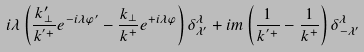<formula> <loc_0><loc_0><loc_500><loc_500>i \lambda \left ( \frac { k _ { \perp } ^ { \prime } } { k ^ { ^ { \prime } + } } e ^ { - i \lambda \varphi ^ { \prime } } - \frac { k _ { \perp } } { k ^ { + } } e ^ { + i \lambda \varphi } \right ) \delta _ { \lambda ^ { \prime } } ^ { \lambda } + i m \left ( \frac { 1 } { k ^ { ^ { \prime } + } } - \frac { 1 } { k ^ { + } } \right ) \delta _ { - \lambda ^ { \prime } } ^ { \lambda }</formula> 